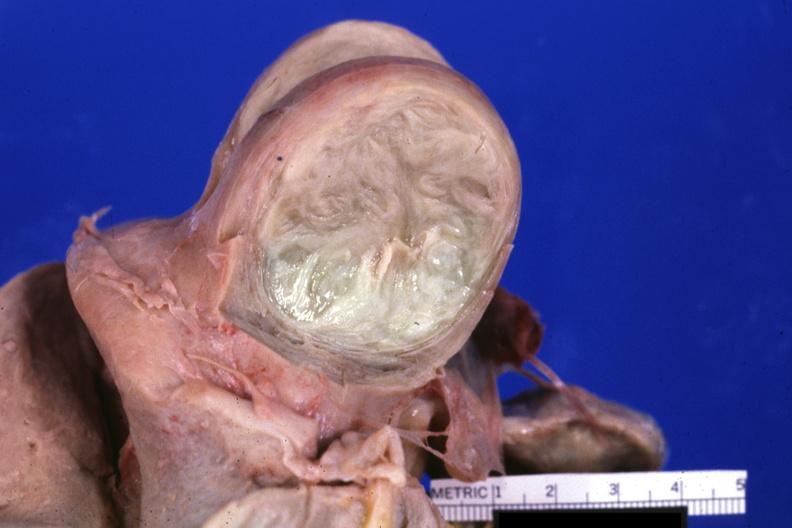does mesothelioma show fixed tissue cut surface of typical myoma?
Answer the question using a single word or phrase. No 